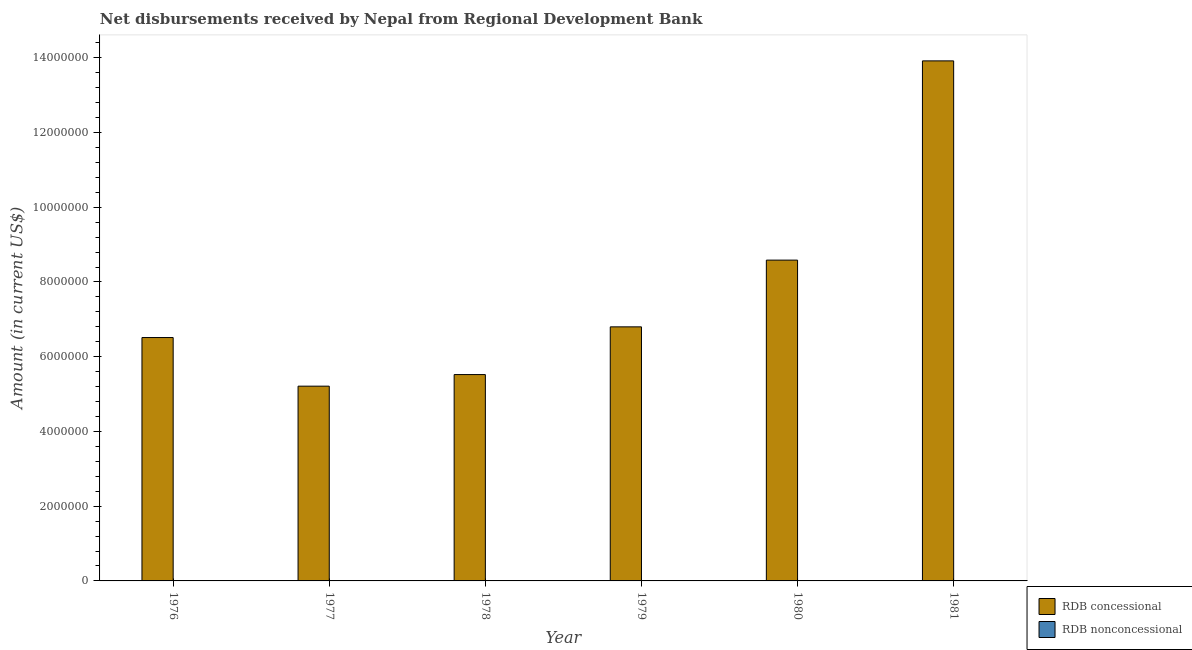How many different coloured bars are there?
Offer a terse response. 1. Are the number of bars on each tick of the X-axis equal?
Your answer should be compact. Yes. What is the label of the 4th group of bars from the left?
Give a very brief answer. 1979. What is the net concessional disbursements from rdb in 1978?
Keep it short and to the point. 5.52e+06. Across all years, what is the maximum net concessional disbursements from rdb?
Give a very brief answer. 1.39e+07. Across all years, what is the minimum net non concessional disbursements from rdb?
Your answer should be compact. 0. What is the total net concessional disbursements from rdb in the graph?
Provide a short and direct response. 4.65e+07. What is the difference between the net concessional disbursements from rdb in 1976 and that in 1979?
Ensure brevity in your answer.  -2.86e+05. What is the ratio of the net concessional disbursements from rdb in 1980 to that in 1981?
Make the answer very short. 0.62. What is the difference between the highest and the second highest net concessional disbursements from rdb?
Make the answer very short. 5.33e+06. What is the difference between the highest and the lowest net concessional disbursements from rdb?
Provide a short and direct response. 8.70e+06. In how many years, is the net non concessional disbursements from rdb greater than the average net non concessional disbursements from rdb taken over all years?
Make the answer very short. 0. Is the sum of the net concessional disbursements from rdb in 1978 and 1980 greater than the maximum net non concessional disbursements from rdb across all years?
Give a very brief answer. Yes. How many bars are there?
Your answer should be compact. 6. Does the graph contain any zero values?
Your response must be concise. Yes. How many legend labels are there?
Your response must be concise. 2. How are the legend labels stacked?
Your response must be concise. Vertical. What is the title of the graph?
Provide a short and direct response. Net disbursements received by Nepal from Regional Development Bank. What is the Amount (in current US$) in RDB concessional in 1976?
Provide a succinct answer. 6.51e+06. What is the Amount (in current US$) in RDB concessional in 1977?
Make the answer very short. 5.21e+06. What is the Amount (in current US$) of RDB concessional in 1978?
Your response must be concise. 5.52e+06. What is the Amount (in current US$) in RDB nonconcessional in 1978?
Provide a succinct answer. 0. What is the Amount (in current US$) in RDB concessional in 1979?
Offer a very short reply. 6.80e+06. What is the Amount (in current US$) of RDB concessional in 1980?
Give a very brief answer. 8.58e+06. What is the Amount (in current US$) in RDB nonconcessional in 1980?
Your response must be concise. 0. What is the Amount (in current US$) of RDB concessional in 1981?
Give a very brief answer. 1.39e+07. Across all years, what is the maximum Amount (in current US$) of RDB concessional?
Ensure brevity in your answer.  1.39e+07. Across all years, what is the minimum Amount (in current US$) in RDB concessional?
Provide a succinct answer. 5.21e+06. What is the total Amount (in current US$) in RDB concessional in the graph?
Ensure brevity in your answer.  4.65e+07. What is the total Amount (in current US$) of RDB nonconcessional in the graph?
Offer a terse response. 0. What is the difference between the Amount (in current US$) of RDB concessional in 1976 and that in 1977?
Your answer should be compact. 1.30e+06. What is the difference between the Amount (in current US$) in RDB concessional in 1976 and that in 1978?
Keep it short and to the point. 9.91e+05. What is the difference between the Amount (in current US$) in RDB concessional in 1976 and that in 1979?
Offer a terse response. -2.86e+05. What is the difference between the Amount (in current US$) in RDB concessional in 1976 and that in 1980?
Offer a very short reply. -2.07e+06. What is the difference between the Amount (in current US$) in RDB concessional in 1976 and that in 1981?
Your answer should be compact. -7.40e+06. What is the difference between the Amount (in current US$) of RDB concessional in 1977 and that in 1978?
Provide a succinct answer. -3.10e+05. What is the difference between the Amount (in current US$) in RDB concessional in 1977 and that in 1979?
Ensure brevity in your answer.  -1.59e+06. What is the difference between the Amount (in current US$) of RDB concessional in 1977 and that in 1980?
Keep it short and to the point. -3.37e+06. What is the difference between the Amount (in current US$) of RDB concessional in 1977 and that in 1981?
Offer a terse response. -8.70e+06. What is the difference between the Amount (in current US$) in RDB concessional in 1978 and that in 1979?
Provide a succinct answer. -1.28e+06. What is the difference between the Amount (in current US$) in RDB concessional in 1978 and that in 1980?
Your answer should be very brief. -3.06e+06. What is the difference between the Amount (in current US$) in RDB concessional in 1978 and that in 1981?
Your answer should be very brief. -8.40e+06. What is the difference between the Amount (in current US$) in RDB concessional in 1979 and that in 1980?
Ensure brevity in your answer.  -1.79e+06. What is the difference between the Amount (in current US$) of RDB concessional in 1979 and that in 1981?
Your response must be concise. -7.12e+06. What is the difference between the Amount (in current US$) in RDB concessional in 1980 and that in 1981?
Your answer should be very brief. -5.33e+06. What is the average Amount (in current US$) of RDB concessional per year?
Offer a very short reply. 7.76e+06. What is the ratio of the Amount (in current US$) in RDB concessional in 1976 to that in 1977?
Offer a very short reply. 1.25. What is the ratio of the Amount (in current US$) of RDB concessional in 1976 to that in 1978?
Ensure brevity in your answer.  1.18. What is the ratio of the Amount (in current US$) in RDB concessional in 1976 to that in 1979?
Offer a very short reply. 0.96. What is the ratio of the Amount (in current US$) in RDB concessional in 1976 to that in 1980?
Your answer should be compact. 0.76. What is the ratio of the Amount (in current US$) in RDB concessional in 1976 to that in 1981?
Ensure brevity in your answer.  0.47. What is the ratio of the Amount (in current US$) of RDB concessional in 1977 to that in 1978?
Your answer should be compact. 0.94. What is the ratio of the Amount (in current US$) in RDB concessional in 1977 to that in 1979?
Make the answer very short. 0.77. What is the ratio of the Amount (in current US$) of RDB concessional in 1977 to that in 1980?
Make the answer very short. 0.61. What is the ratio of the Amount (in current US$) of RDB concessional in 1977 to that in 1981?
Your response must be concise. 0.37. What is the ratio of the Amount (in current US$) of RDB concessional in 1978 to that in 1979?
Your answer should be very brief. 0.81. What is the ratio of the Amount (in current US$) of RDB concessional in 1978 to that in 1980?
Make the answer very short. 0.64. What is the ratio of the Amount (in current US$) in RDB concessional in 1978 to that in 1981?
Your response must be concise. 0.4. What is the ratio of the Amount (in current US$) in RDB concessional in 1979 to that in 1980?
Provide a succinct answer. 0.79. What is the ratio of the Amount (in current US$) in RDB concessional in 1979 to that in 1981?
Your answer should be compact. 0.49. What is the ratio of the Amount (in current US$) of RDB concessional in 1980 to that in 1981?
Provide a succinct answer. 0.62. What is the difference between the highest and the second highest Amount (in current US$) in RDB concessional?
Offer a terse response. 5.33e+06. What is the difference between the highest and the lowest Amount (in current US$) in RDB concessional?
Ensure brevity in your answer.  8.70e+06. 